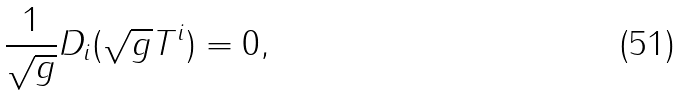Convert formula to latex. <formula><loc_0><loc_0><loc_500><loc_500>\frac { 1 } { \sqrt { g } } D _ { i } ( \sqrt { g } T ^ { i } ) = 0 ,</formula> 